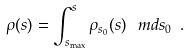<formula> <loc_0><loc_0><loc_500><loc_500>\rho ( s ) = \int _ { s _ { \max } } ^ { s } \rho _ { s _ { 0 } } ( s ) \, \ m d s _ { 0 } \ .</formula> 